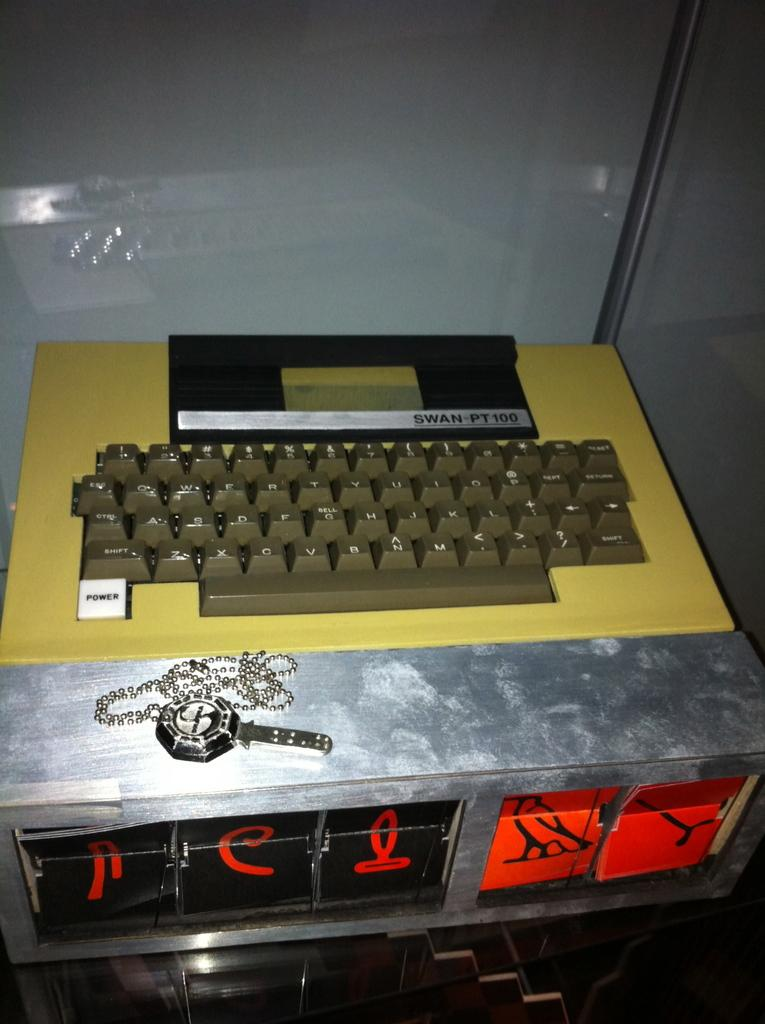Provide a one-sentence caption for the provided image. A Swan Pt 100 keyboard that has a power on button built into a metal box. 